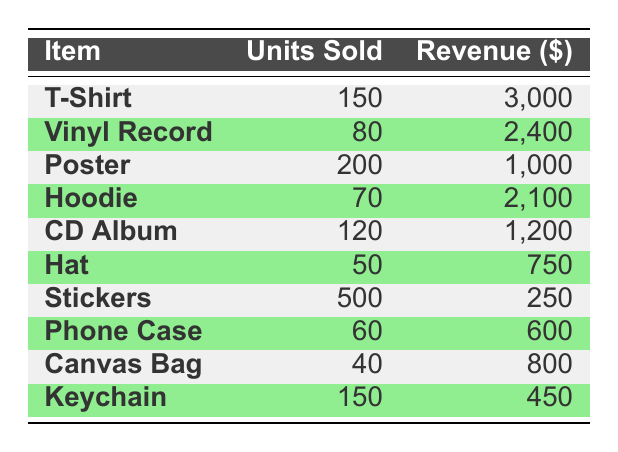What's the total revenue generated from merchandise sales? To find the total revenue, sum the revenue generated from each item: 3000 + 2400 + 1000 + 2100 + 1200 + 750 + 250 + 600 + 800 + 450 = 10300.
Answer: 10300 Which item had the highest number of units sold? Looking through the table, the item with the highest units sold is the T-Shirt, with 150 units sold, which is greater than the units sold for any other item.
Answer: T-Shirt How much revenue was generated from selling Hoodies? The revenue generated from selling Hoodies is listed as 2100 in the table.
Answer: 2100 What is the average revenue generated per item sold? First, calculate the total revenue which is 10300. There are 10 merchandise items, so the average revenue per item is 10300 / 10 = 1030.
Answer: 1030 Did the number of Keychains sold exceed the number of Phone Cases sold? The table shows that 150 Keychains were sold and only 60 Phone Cases were sold. Since 150 is greater than 60, the statement is true.
Answer: Yes What is the total revenue generated from the top three merchandise items by revenue? The top three items by revenue are T-Shirt (3000), Vinyl Record (2400), and Hoodie (2100). Adding these revenues gives 3000 + 2400 + 2100 = 7500.
Answer: 7500 If I sold 100 more Stickers, what would the new total revenue be? The current revenue from Stickers is 250. The additional revenue from selling 100 more Stickers (assuming the same price per sticker) would be 100 * (250/500) = 50. Adding this to the current total (10300 + 50) gives 10350.
Answer: 10350 How much revenue was generated from selling the fewest units? The item with the fewest units sold is the Canvas Bag with 40 units, generating 800 in revenue.
Answer: 800 Is the revenue generated from CDs higher than that from Hats? The revenue from the CD Album is 1200 and from Hats is 750. Since 1200 is greater than 750, the statement is true.
Answer: Yes 